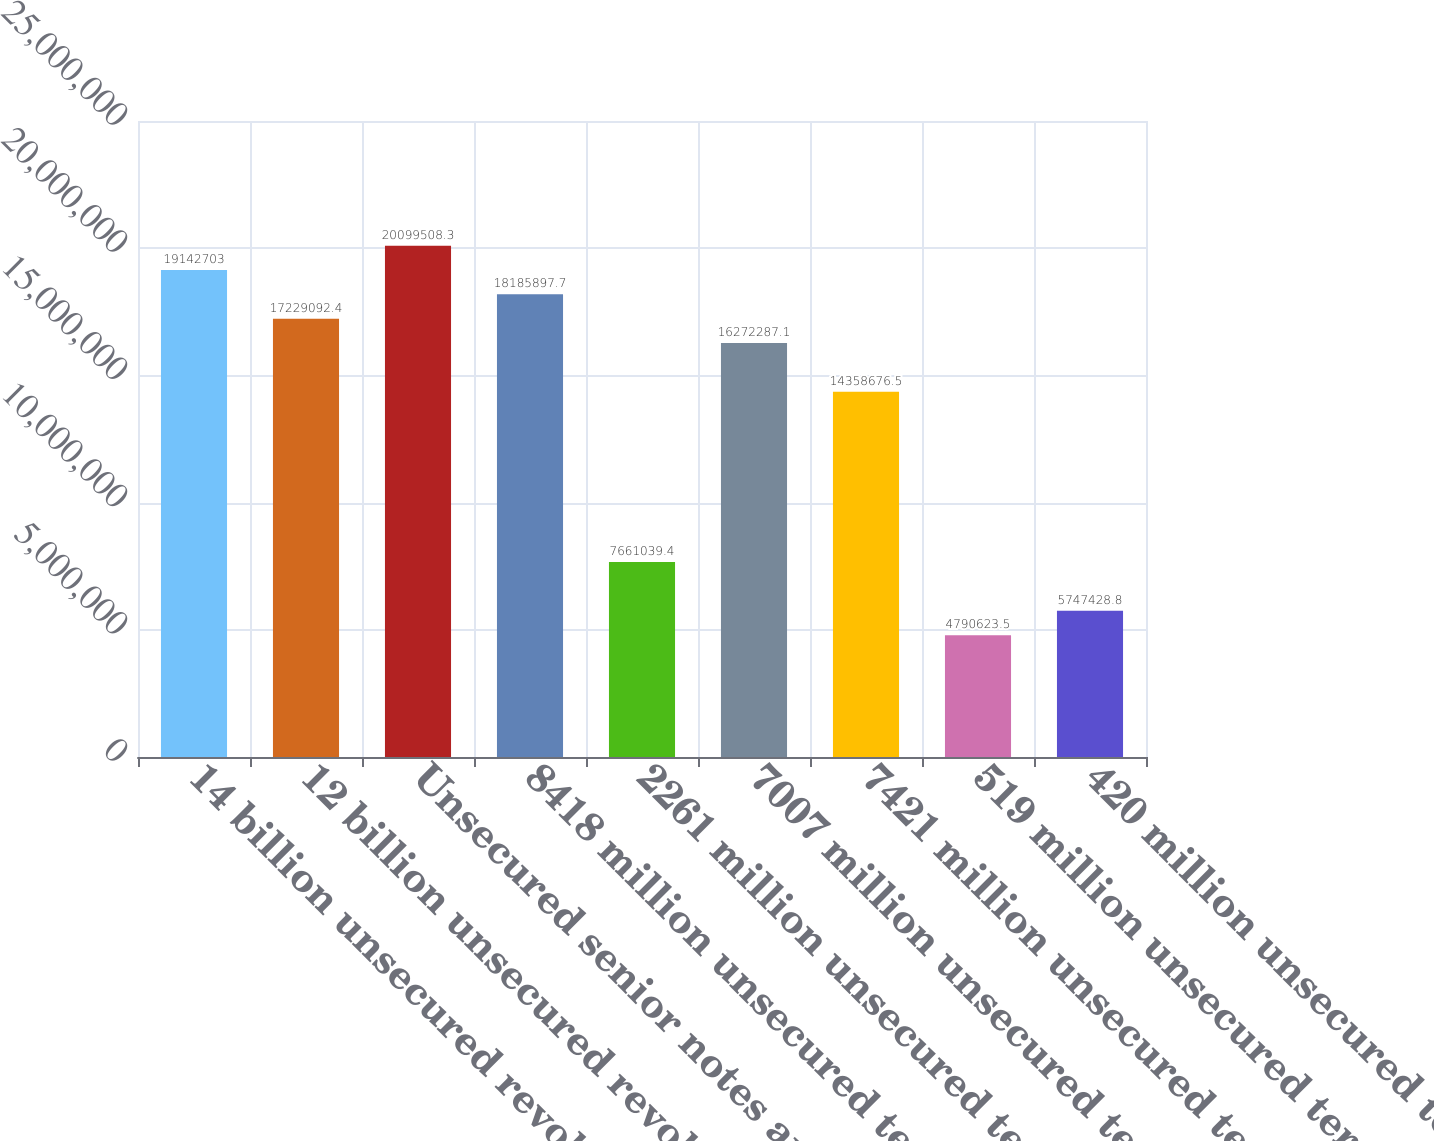Convert chart. <chart><loc_0><loc_0><loc_500><loc_500><bar_chart><fcel>14 billion unsecured revolving<fcel>12 billion unsecured revolving<fcel>Unsecured senior notes and<fcel>8418 million unsecured term<fcel>2261 million unsecured term<fcel>7007 million unsecured term<fcel>7421 million unsecured term<fcel>519 million unsecured term<fcel>420 million unsecured term<nl><fcel>1.91427e+07<fcel>1.72291e+07<fcel>2.00995e+07<fcel>1.81859e+07<fcel>7.66104e+06<fcel>1.62723e+07<fcel>1.43587e+07<fcel>4.79062e+06<fcel>5.74743e+06<nl></chart> 